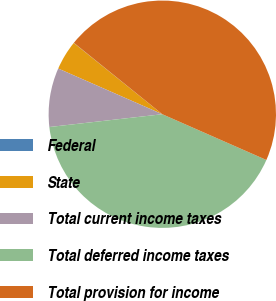<chart> <loc_0><loc_0><loc_500><loc_500><pie_chart><fcel>Federal<fcel>State<fcel>Total current income taxes<fcel>Total deferred income taxes<fcel>Total provision for income<nl><fcel>0.03%<fcel>4.2%<fcel>8.38%<fcel>41.61%<fcel>45.78%<nl></chart> 